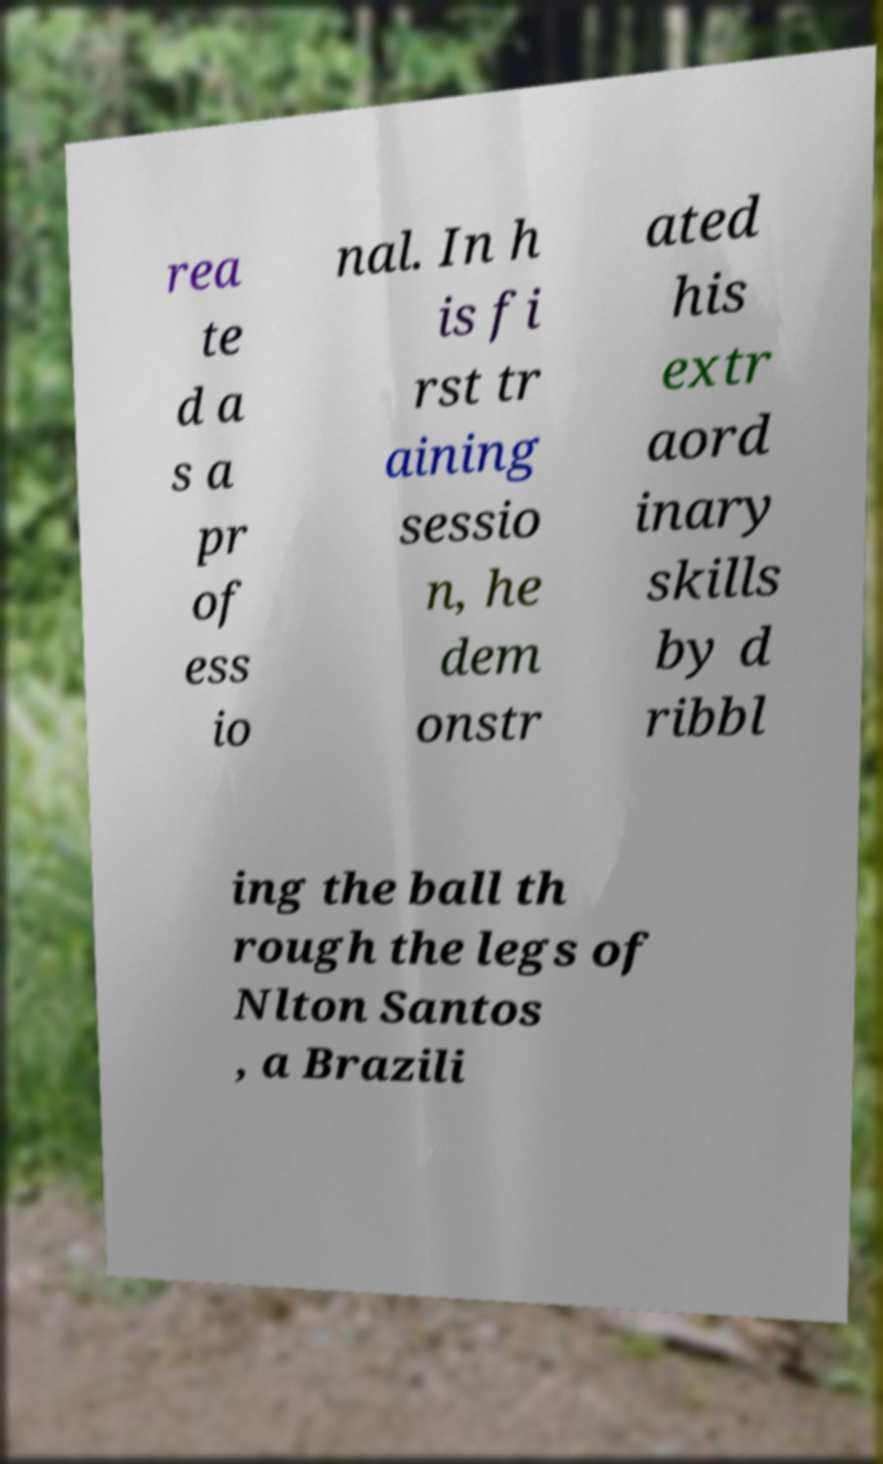I need the written content from this picture converted into text. Can you do that? rea te d a s a pr of ess io nal. In h is fi rst tr aining sessio n, he dem onstr ated his extr aord inary skills by d ribbl ing the ball th rough the legs of Nlton Santos , a Brazili 